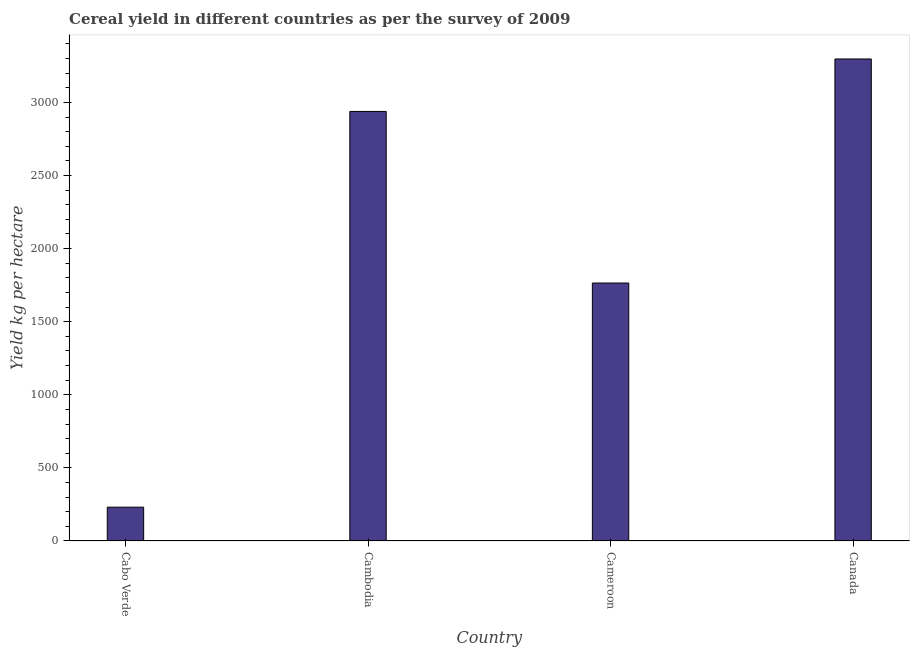Does the graph contain any zero values?
Your answer should be compact. No. Does the graph contain grids?
Make the answer very short. No. What is the title of the graph?
Your answer should be compact. Cereal yield in different countries as per the survey of 2009. What is the label or title of the Y-axis?
Provide a short and direct response. Yield kg per hectare. What is the cereal yield in Cabo Verde?
Your answer should be very brief. 230.84. Across all countries, what is the maximum cereal yield?
Your answer should be compact. 3297.52. Across all countries, what is the minimum cereal yield?
Offer a terse response. 230.84. In which country was the cereal yield maximum?
Offer a terse response. Canada. In which country was the cereal yield minimum?
Provide a short and direct response. Cabo Verde. What is the sum of the cereal yield?
Provide a succinct answer. 8231.49. What is the difference between the cereal yield in Cabo Verde and Cambodia?
Your answer should be very brief. -2707.77. What is the average cereal yield per country?
Your response must be concise. 2057.87. What is the median cereal yield?
Give a very brief answer. 2351.57. In how many countries, is the cereal yield greater than 200 kg per hectare?
Your answer should be very brief. 4. What is the ratio of the cereal yield in Cambodia to that in Cameroon?
Provide a succinct answer. 1.67. What is the difference between the highest and the second highest cereal yield?
Offer a very short reply. 358.9. What is the difference between the highest and the lowest cereal yield?
Give a very brief answer. 3066.68. In how many countries, is the cereal yield greater than the average cereal yield taken over all countries?
Keep it short and to the point. 2. How many bars are there?
Make the answer very short. 4. How many countries are there in the graph?
Offer a terse response. 4. What is the Yield kg per hectare of Cabo Verde?
Your response must be concise. 230.84. What is the Yield kg per hectare of Cambodia?
Keep it short and to the point. 2938.61. What is the Yield kg per hectare in Cameroon?
Your answer should be very brief. 1764.52. What is the Yield kg per hectare of Canada?
Offer a terse response. 3297.52. What is the difference between the Yield kg per hectare in Cabo Verde and Cambodia?
Provide a short and direct response. -2707.77. What is the difference between the Yield kg per hectare in Cabo Verde and Cameroon?
Provide a succinct answer. -1533.68. What is the difference between the Yield kg per hectare in Cabo Verde and Canada?
Provide a short and direct response. -3066.68. What is the difference between the Yield kg per hectare in Cambodia and Cameroon?
Your response must be concise. 1174.09. What is the difference between the Yield kg per hectare in Cambodia and Canada?
Offer a terse response. -358.9. What is the difference between the Yield kg per hectare in Cameroon and Canada?
Your response must be concise. -1533. What is the ratio of the Yield kg per hectare in Cabo Verde to that in Cambodia?
Your answer should be very brief. 0.08. What is the ratio of the Yield kg per hectare in Cabo Verde to that in Cameroon?
Your answer should be very brief. 0.13. What is the ratio of the Yield kg per hectare in Cabo Verde to that in Canada?
Your response must be concise. 0.07. What is the ratio of the Yield kg per hectare in Cambodia to that in Cameroon?
Give a very brief answer. 1.67. What is the ratio of the Yield kg per hectare in Cambodia to that in Canada?
Offer a terse response. 0.89. What is the ratio of the Yield kg per hectare in Cameroon to that in Canada?
Offer a terse response. 0.54. 